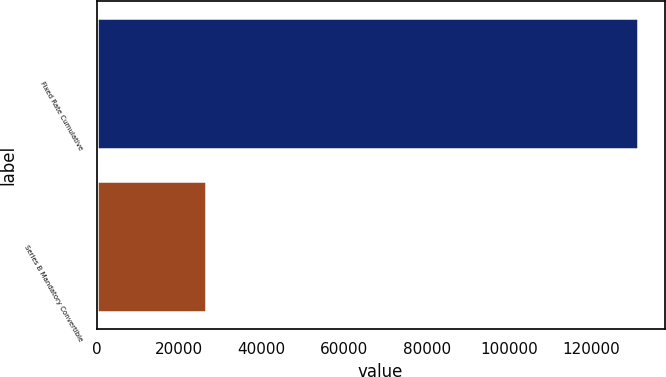Convert chart. <chart><loc_0><loc_0><loc_500><loc_500><bar_chart><fcel>Fixed Rate Cumulative<fcel>Series B Mandatory Convertible<nl><fcel>131155<fcel>26500<nl></chart> 